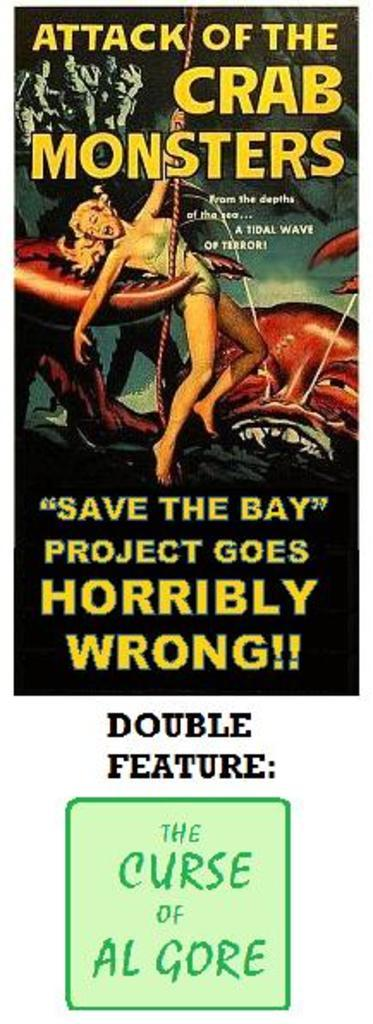<image>
Present a compact description of the photo's key features. A poster advertises a movie called "Attack of the Crab Monsters." 